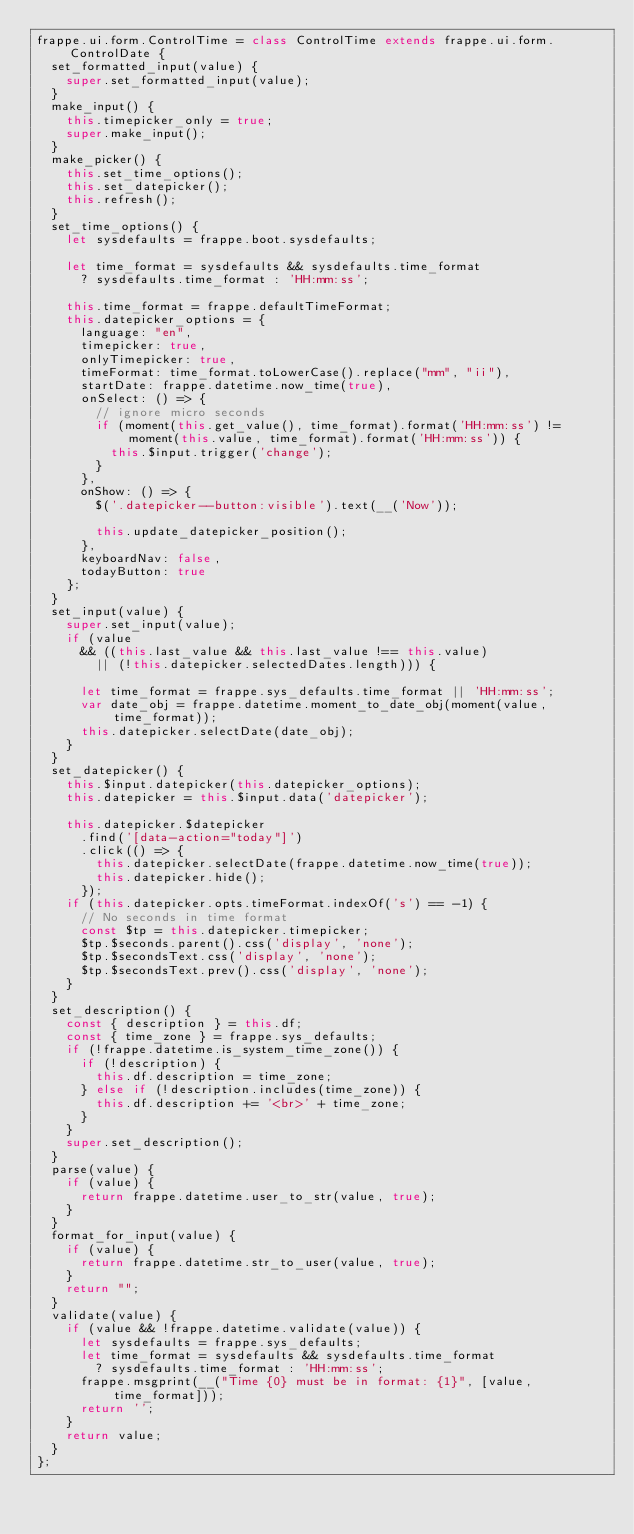Convert code to text. <code><loc_0><loc_0><loc_500><loc_500><_JavaScript_>frappe.ui.form.ControlTime = class ControlTime extends frappe.ui.form.ControlDate {
	set_formatted_input(value) {
		super.set_formatted_input(value);
	}
	make_input() {
		this.timepicker_only = true;
		super.make_input();
	}
	make_picker() {
		this.set_time_options();
		this.set_datepicker();
		this.refresh();
	}
	set_time_options() {
		let sysdefaults = frappe.boot.sysdefaults;

		let time_format = sysdefaults && sysdefaults.time_format
			? sysdefaults.time_format : 'HH:mm:ss';

		this.time_format = frappe.defaultTimeFormat;
		this.datepicker_options = {
			language: "en",
			timepicker: true,
			onlyTimepicker: true,
			timeFormat: time_format.toLowerCase().replace("mm", "ii"),
			startDate: frappe.datetime.now_time(true),
			onSelect: () => {
				// ignore micro seconds
				if (moment(this.get_value(), time_format).format('HH:mm:ss') != moment(this.value, time_format).format('HH:mm:ss')) {
					this.$input.trigger('change');
				}
			},
			onShow: () => {
				$('.datepicker--button:visible').text(__('Now'));

				this.update_datepicker_position();
			},
			keyboardNav: false,
			todayButton: true
		};
	}
	set_input(value) {
		super.set_input(value);
		if (value
			&& ((this.last_value && this.last_value !== this.value)
				|| (!this.datepicker.selectedDates.length))) {

			let time_format = frappe.sys_defaults.time_format || 'HH:mm:ss';
			var date_obj = frappe.datetime.moment_to_date_obj(moment(value, time_format));
			this.datepicker.selectDate(date_obj);
		}
	}
	set_datepicker() {
		this.$input.datepicker(this.datepicker_options);
		this.datepicker = this.$input.data('datepicker');

		this.datepicker.$datepicker
			.find('[data-action="today"]')
			.click(() => {
				this.datepicker.selectDate(frappe.datetime.now_time(true));
				this.datepicker.hide();
			});
		if (this.datepicker.opts.timeFormat.indexOf('s') == -1) {
			// No seconds in time format
			const $tp = this.datepicker.timepicker;
			$tp.$seconds.parent().css('display', 'none');
			$tp.$secondsText.css('display', 'none');
			$tp.$secondsText.prev().css('display', 'none');
		}
	}
	set_description() {
		const { description } = this.df;
		const { time_zone } = frappe.sys_defaults;
		if (!frappe.datetime.is_system_time_zone()) {
			if (!description) {
				this.df.description = time_zone;
			} else if (!description.includes(time_zone)) {
				this.df.description += '<br>' + time_zone;
			}
		}
		super.set_description();
	}
	parse(value) {
		if (value) {
			return frappe.datetime.user_to_str(value, true);
		}
	}
	format_for_input(value) {
		if (value) {
			return frappe.datetime.str_to_user(value, true);
		}
		return "";
	}
	validate(value) {
		if (value && !frappe.datetime.validate(value)) {
			let sysdefaults = frappe.sys_defaults;
			let time_format = sysdefaults && sysdefaults.time_format
				? sysdefaults.time_format : 'HH:mm:ss';
			frappe.msgprint(__("Time {0} must be in format: {1}", [value, time_format]));
			return '';
		}
		return value;
	}
};
</code> 